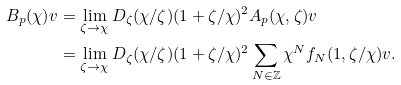Convert formula to latex. <formula><loc_0><loc_0><loc_500><loc_500>B _ { p } ( \chi ) v & = \lim _ { \zeta \to \chi } D _ { \zeta } ( \chi / \zeta ) ( 1 + \zeta / \chi ) ^ { 2 } A _ { p } ( \chi , \zeta ) v \\ & = \lim _ { \zeta \to \chi } D _ { \zeta } ( \chi / \zeta ) ( 1 + \zeta / \chi ) ^ { 2 } \sum _ { N \in \mathbb { Z } } \chi ^ { N } f _ { N } ( 1 , \zeta / \chi ) v .</formula> 